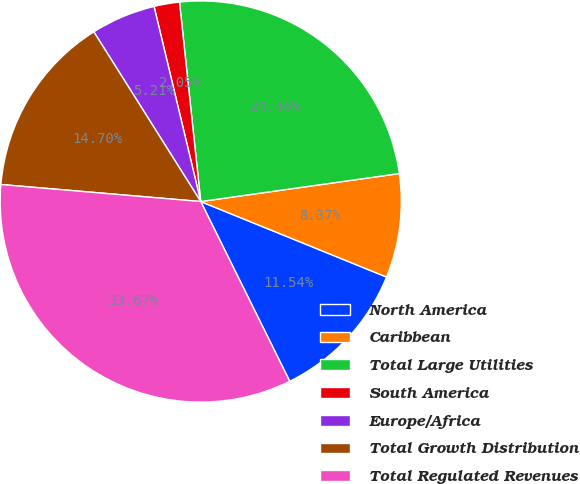<chart> <loc_0><loc_0><loc_500><loc_500><pie_chart><fcel>North America<fcel>Caribbean<fcel>Total Large Utilities<fcel>South America<fcel>Europe/Africa<fcel>Total Growth Distribution<fcel>Total Regulated Revenues<nl><fcel>11.54%<fcel>8.37%<fcel>24.46%<fcel>2.05%<fcel>5.21%<fcel>14.7%<fcel>33.67%<nl></chart> 